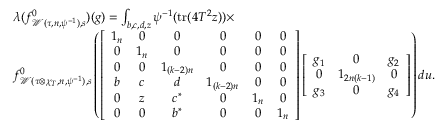Convert formula to latex. <formula><loc_0><loc_0><loc_500><loc_500>\begin{array} { r l } & { \lambda ( f _ { \mathcal { W } ( \tau , n , \psi ^ { - 1 } ) , s } ^ { 0 } ) ( g ) = \int _ { b , c , d , z } \psi ^ { - 1 } ( t r ( 4 T ^ { 2 } z ) ) \times } \\ & { f _ { \mathcal { W } ( \tau \otimes \chi _ { T } , n , \psi ^ { - 1 } ) , s } ^ { 0 } \left ( \left [ \begin{array} { c c c c c c } { 1 _ { n } } & { 0 } & { 0 } & { 0 } & { 0 } & { 0 } \\ { 0 } & { 1 _ { n } } & { 0 } & { 0 } & { 0 } & { 0 } \\ { 0 } & { 0 } & { 1 _ { ( k - 2 ) n } } & { 0 } & { 0 } & { 0 } \\ { b } & { c } & { d } & { 1 _ { ( k - 2 ) n } } & { 0 } & { 0 } \\ { 0 } & { z } & { c ^ { \ast } } & { 0 } & { 1 _ { n } } & { 0 } \\ { 0 } & { 0 } & { b ^ { \ast } } & { 0 } & { 0 } & { 1 _ { n } } \end{array} \right ] \left [ \begin{array} { c c c } { g _ { 1 } } & { 0 } & { g _ { 2 } } \\ { 0 } & { 1 _ { 2 n ( k - 1 ) } } & { 0 } \\ { g _ { 3 } } & { 0 } & { g _ { 4 } } \end{array} \right ] \right ) d u . } \end{array}</formula> 